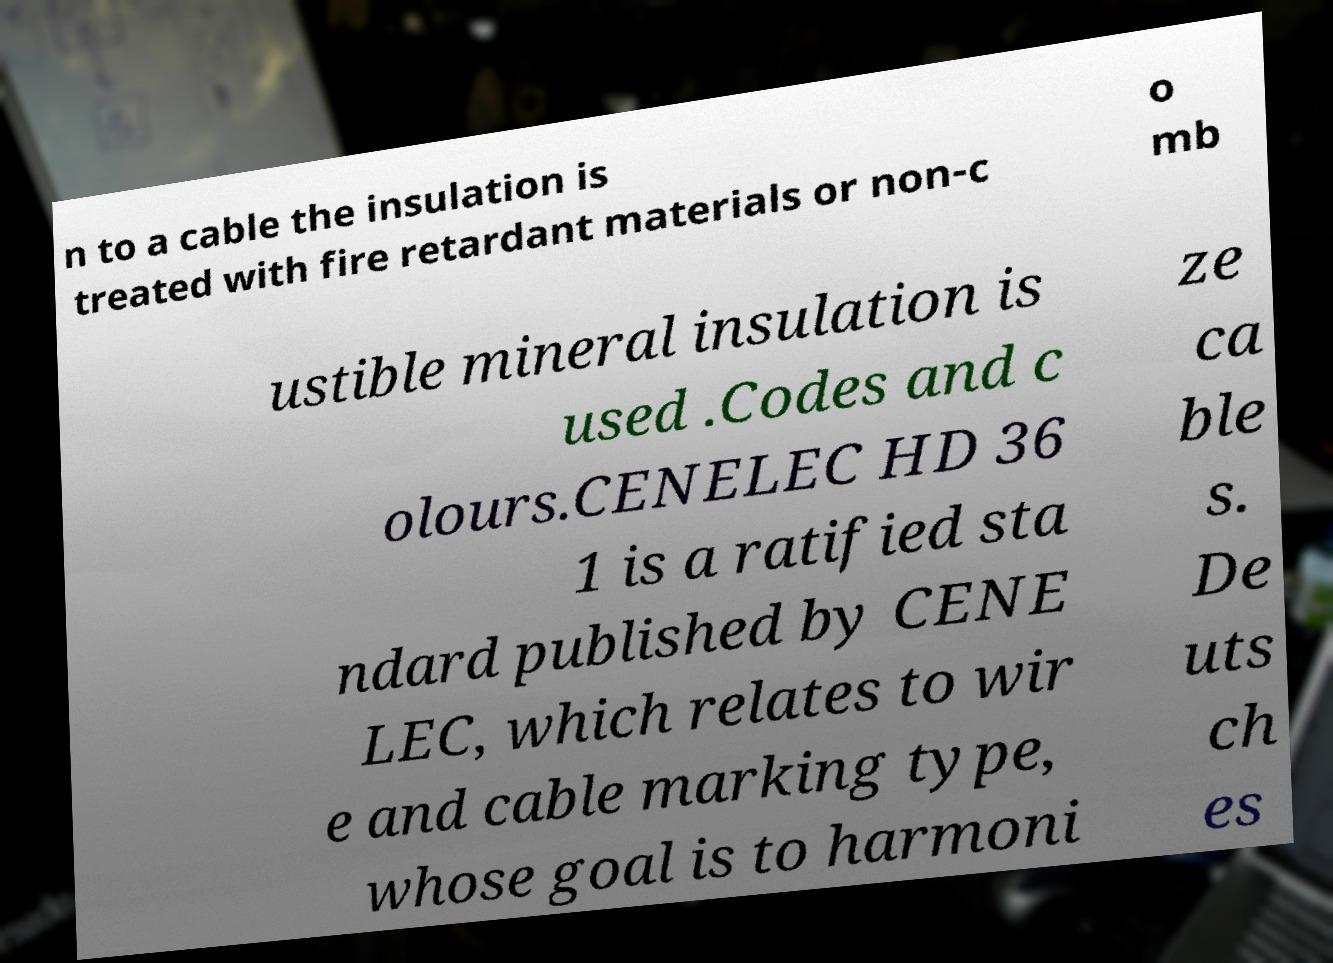For documentation purposes, I need the text within this image transcribed. Could you provide that? n to a cable the insulation is treated with fire retardant materials or non-c o mb ustible mineral insulation is used .Codes and c olours.CENELEC HD 36 1 is a ratified sta ndard published by CENE LEC, which relates to wir e and cable marking type, whose goal is to harmoni ze ca ble s. De uts ch es 